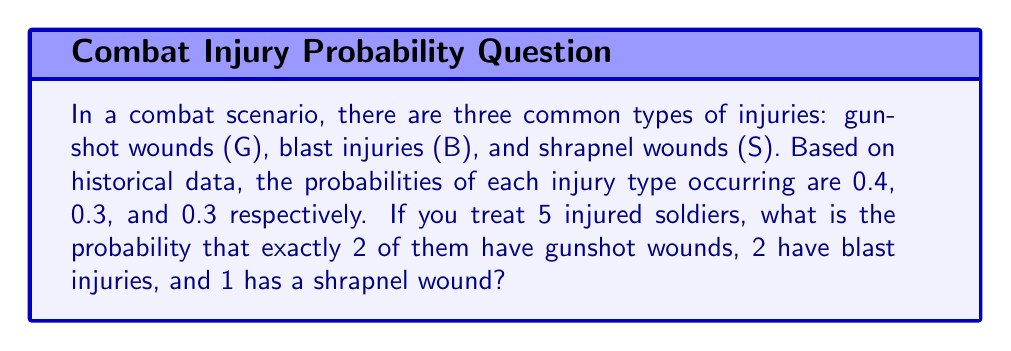What is the answer to this math problem? To solve this problem, we'll use the concept of multinomial probability. The multinomial distribution is an extension of the binomial distribution for scenarios with more than two outcomes.

Step 1: Identify the parameters
- Number of trials (injured soldiers): $n = 5$
- Probability of gunshot wound: $p_G = 0.4$
- Probability of blast injury: $p_B = 0.3$
- Probability of shrapnel wound: $p_S = 0.3$
- Number of each injury type: $x_G = 2$, $x_B = 2$, $x_S = 1$

Step 2: Apply the multinomial probability formula
The formula for multinomial probability is:

$$ P(X_1 = x_1, X_2 = x_2, ..., X_k = x_k) = \frac{n!}{x_1! x_2! ... x_k!} p_1^{x_1} p_2^{x_2} ... p_k^{x_k} $$

Substituting our values:

$$ P(X_G = 2, X_B = 2, X_S = 1) = \frac{5!}{2! 2! 1!} (0.4)^2 (0.3)^2 (0.3)^1 $$

Step 3: Calculate the result
$$ \begin{aligned}
P(X_G = 2, X_B = 2, X_S = 1) &= \frac{5 \cdot 4 \cdot 3 \cdot 2 \cdot 1}{(2 \cdot 1)(2 \cdot 1)(1)} \cdot 0.16 \cdot 0.09 \cdot 0.3 \\
&= \frac{120}{4} \cdot 0.16 \cdot 0.09 \cdot 0.3 \\
&= 30 \cdot 0.16 \cdot 0.09 \cdot 0.3 \\
&= 0.1296
\end{aligned} $$

Therefore, the probability of exactly 2 gunshot wounds, 2 blast injuries, and 1 shrapnel wound among 5 injured soldiers is approximately 0.1296 or 12.96%.
Answer: 0.1296 